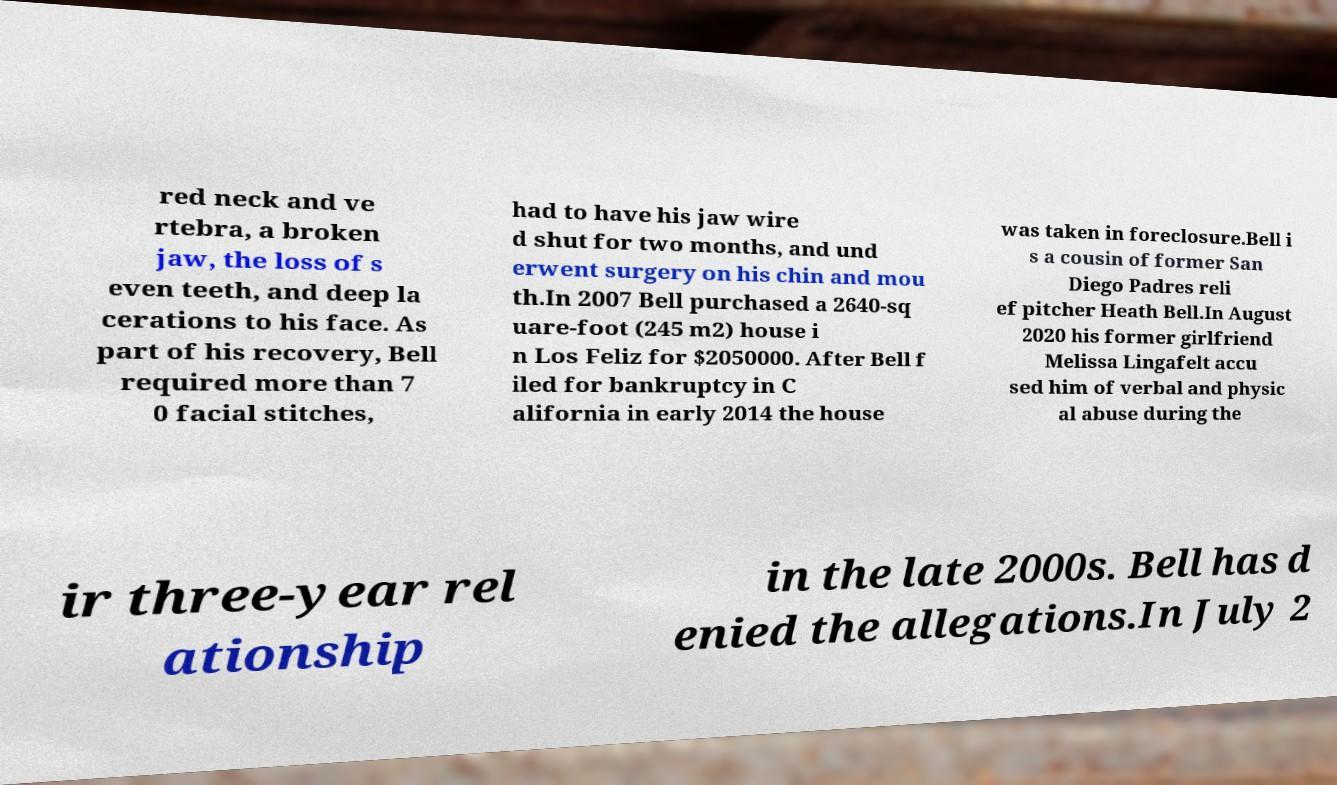Can you accurately transcribe the text from the provided image for me? red neck and ve rtebra, a broken jaw, the loss of s even teeth, and deep la cerations to his face. As part of his recovery, Bell required more than 7 0 facial stitches, had to have his jaw wire d shut for two months, and und erwent surgery on his chin and mou th.In 2007 Bell purchased a 2640-sq uare-foot (245 m2) house i n Los Feliz for $2050000. After Bell f iled for bankruptcy in C alifornia in early 2014 the house was taken in foreclosure.Bell i s a cousin of former San Diego Padres reli ef pitcher Heath Bell.In August 2020 his former girlfriend Melissa Lingafelt accu sed him of verbal and physic al abuse during the ir three-year rel ationship in the late 2000s. Bell has d enied the allegations.In July 2 